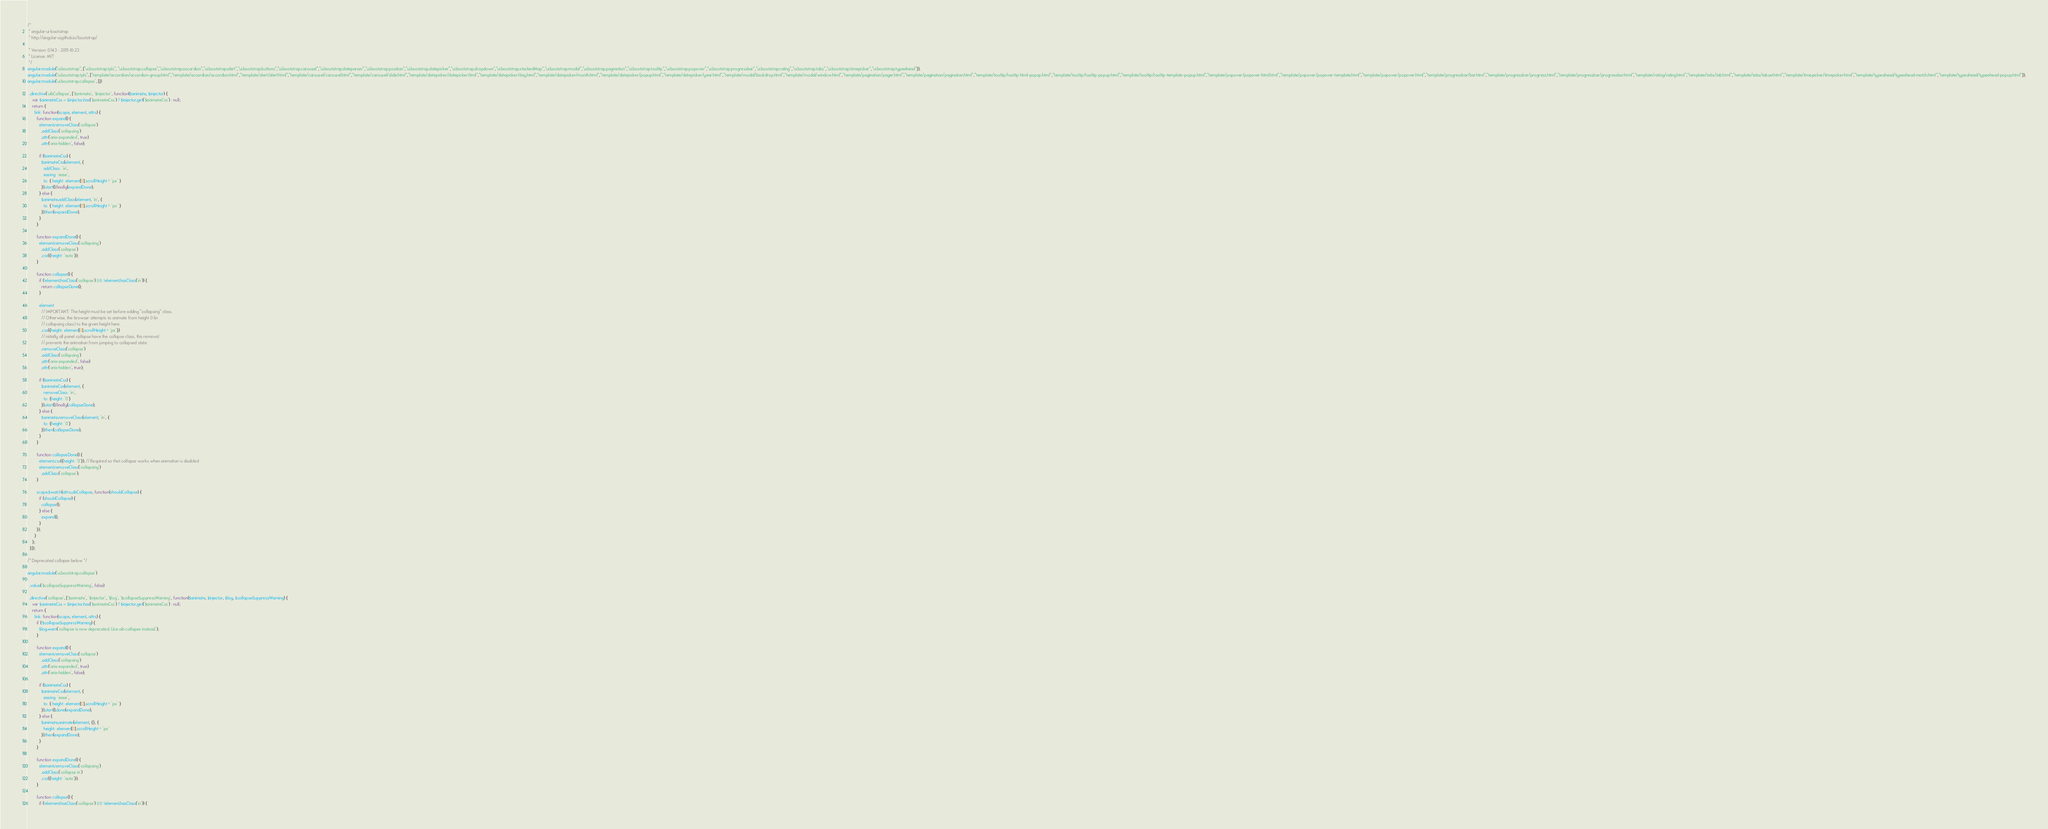Convert code to text. <code><loc_0><loc_0><loc_500><loc_500><_JavaScript_>/*
 * angular-ui-bootstrap
 * http://angular-ui.github.io/bootstrap/

 * Version: 0.14.3 - 2015-10-23
 * License: MIT
 */
angular.module("ui.bootstrap", ["ui.bootstrap.tpls", "ui.bootstrap.collapse","ui.bootstrap.accordion","ui.bootstrap.alert","ui.bootstrap.buttons","ui.bootstrap.carousel","ui.bootstrap.dateparser","ui.bootstrap.position","ui.bootstrap.datepicker","ui.bootstrap.dropdown","ui.bootstrap.stackedMap","ui.bootstrap.modal","ui.bootstrap.pagination","ui.bootstrap.tooltip","ui.bootstrap.popover","ui.bootstrap.progressbar","ui.bootstrap.rating","ui.bootstrap.tabs","ui.bootstrap.timepicker","ui.bootstrap.typeahead"]);
angular.module("ui.bootstrap.tpls", ["template/accordion/accordion-group.html","template/accordion/accordion.html","template/alert/alert.html","template/carousel/carousel.html","template/carousel/slide.html","template/datepicker/datepicker.html","template/datepicker/day.html","template/datepicker/month.html","template/datepicker/popup.html","template/datepicker/year.html","template/modal/backdrop.html","template/modal/window.html","template/pagination/pager.html","template/pagination/pagination.html","template/tooltip/tooltip-html-popup.html","template/tooltip/tooltip-popup.html","template/tooltip/tooltip-template-popup.html","template/popover/popover-html.html","template/popover/popover-template.html","template/popover/popover.html","template/progressbar/bar.html","template/progressbar/progress.html","template/progressbar/progressbar.html","template/rating/rating.html","template/tabs/tab.html","template/tabs/tabset.html","template/timepicker/timepicker.html","template/typeahead/typeahead-match.html","template/typeahead/typeahead-popup.html"]);
angular.module('ui.bootstrap.collapse', [])

  .directive('uibCollapse', ['$animate', '$injector', function($animate, $injector) {
    var $animateCss = $injector.has('$animateCss') ? $injector.get('$animateCss') : null;
    return {
      link: function(scope, element, attrs) {
        function expand() {
          element.removeClass('collapse')
            .addClass('collapsing')
            .attr('aria-expanded', true)
            .attr('aria-hidden', false);

          if ($animateCss) {
            $animateCss(element, {
              addClass: 'in',
              easing: 'ease',
              to: { height: element[0].scrollHeight + 'px' }
            }).start().finally(expandDone);
          } else {
            $animate.addClass(element, 'in', {
              to: { height: element[0].scrollHeight + 'px' }
            }).then(expandDone);
          }
        }

        function expandDone() {
          element.removeClass('collapsing')
            .addClass('collapse')
            .css({height: 'auto'});
        }

        function collapse() {
          if (!element.hasClass('collapse') && !element.hasClass('in')) {
            return collapseDone();
          }

          element
            // IMPORTANT: The height must be set before adding "collapsing" class.
            // Otherwise, the browser attempts to animate from height 0 (in
            // collapsing class) to the given height here.
            .css({height: element[0].scrollHeight + 'px'})
            // initially all panel collapse have the collapse class, this removal
            // prevents the animation from jumping to collapsed state
            .removeClass('collapse')
            .addClass('collapsing')
            .attr('aria-expanded', false)
            .attr('aria-hidden', true);

          if ($animateCss) {
            $animateCss(element, {
              removeClass: 'in',
              to: {height: '0'}
            }).start().finally(collapseDone);
          } else {
            $animate.removeClass(element, 'in', {
              to: {height: '0'}
            }).then(collapseDone);
          }
        }

        function collapseDone() {
          element.css({height: '0'}); // Required so that collapse works when animation is disabled
          element.removeClass('collapsing')
            .addClass('collapse');
        }

        scope.$watch(attrs.uibCollapse, function(shouldCollapse) {
          if (shouldCollapse) {
            collapse();
          } else {
            expand();
          }
        });
      }
    };
  }]);

/* Deprecated collapse below */

angular.module('ui.bootstrap.collapse')

  .value('$collapseSuppressWarning', false)

  .directive('collapse', ['$animate', '$injector', '$log', '$collapseSuppressWarning', function($animate, $injector, $log, $collapseSuppressWarning) {
    var $animateCss = $injector.has('$animateCss') ? $injector.get('$animateCss') : null;
    return {
      link: function(scope, element, attrs) {
        if (!$collapseSuppressWarning) {
          $log.warn('collapse is now deprecated. Use uib-collapse instead.');
        }

        function expand() {
          element.removeClass('collapse')
            .addClass('collapsing')
            .attr('aria-expanded', true)
            .attr('aria-hidden', false);

          if ($animateCss) {
            $animateCss(element, {
              easing: 'ease',
              to: { height: element[0].scrollHeight + 'px' }
            }).start().done(expandDone);
          } else {
            $animate.animate(element, {}, {
              height: element[0].scrollHeight + 'px'
            }).then(expandDone);
          }
        }

        function expandDone() {
          element.removeClass('collapsing')
            .addClass('collapse in')
            .css({height: 'auto'});
        }

        function collapse() {
          if (!element.hasClass('collapse') && !element.hasClass('in')) {</code> 